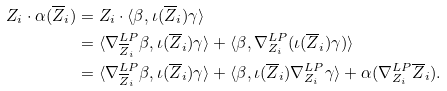Convert formula to latex. <formula><loc_0><loc_0><loc_500><loc_500>Z _ { i } \cdot \alpha ( \overline { Z } _ { i } ) & = Z _ { i } \cdot \langle \beta , \iota ( \overline { Z } _ { i } ) \gamma \rangle \\ & = \langle \nabla ^ { L P } _ { \overline { Z } _ { i } } \beta , \iota ( \overline { Z } _ { i } ) \gamma \rangle + \langle \beta , \nabla ^ { L P } _ { Z _ { i } } ( \iota ( \overline { Z } _ { i } ) \gamma ) \rangle \\ & = \langle \nabla ^ { L P } _ { \overline { Z } _ { i } } \beta , \iota ( \overline { Z } _ { i } ) \gamma \rangle + \langle \beta , \iota ( \overline { Z } _ { i } ) \nabla ^ { L P } _ { Z _ { i } } \gamma \rangle + \alpha ( \nabla ^ { L P } _ { Z _ { i } } \overline { Z } _ { i } ) .</formula> 